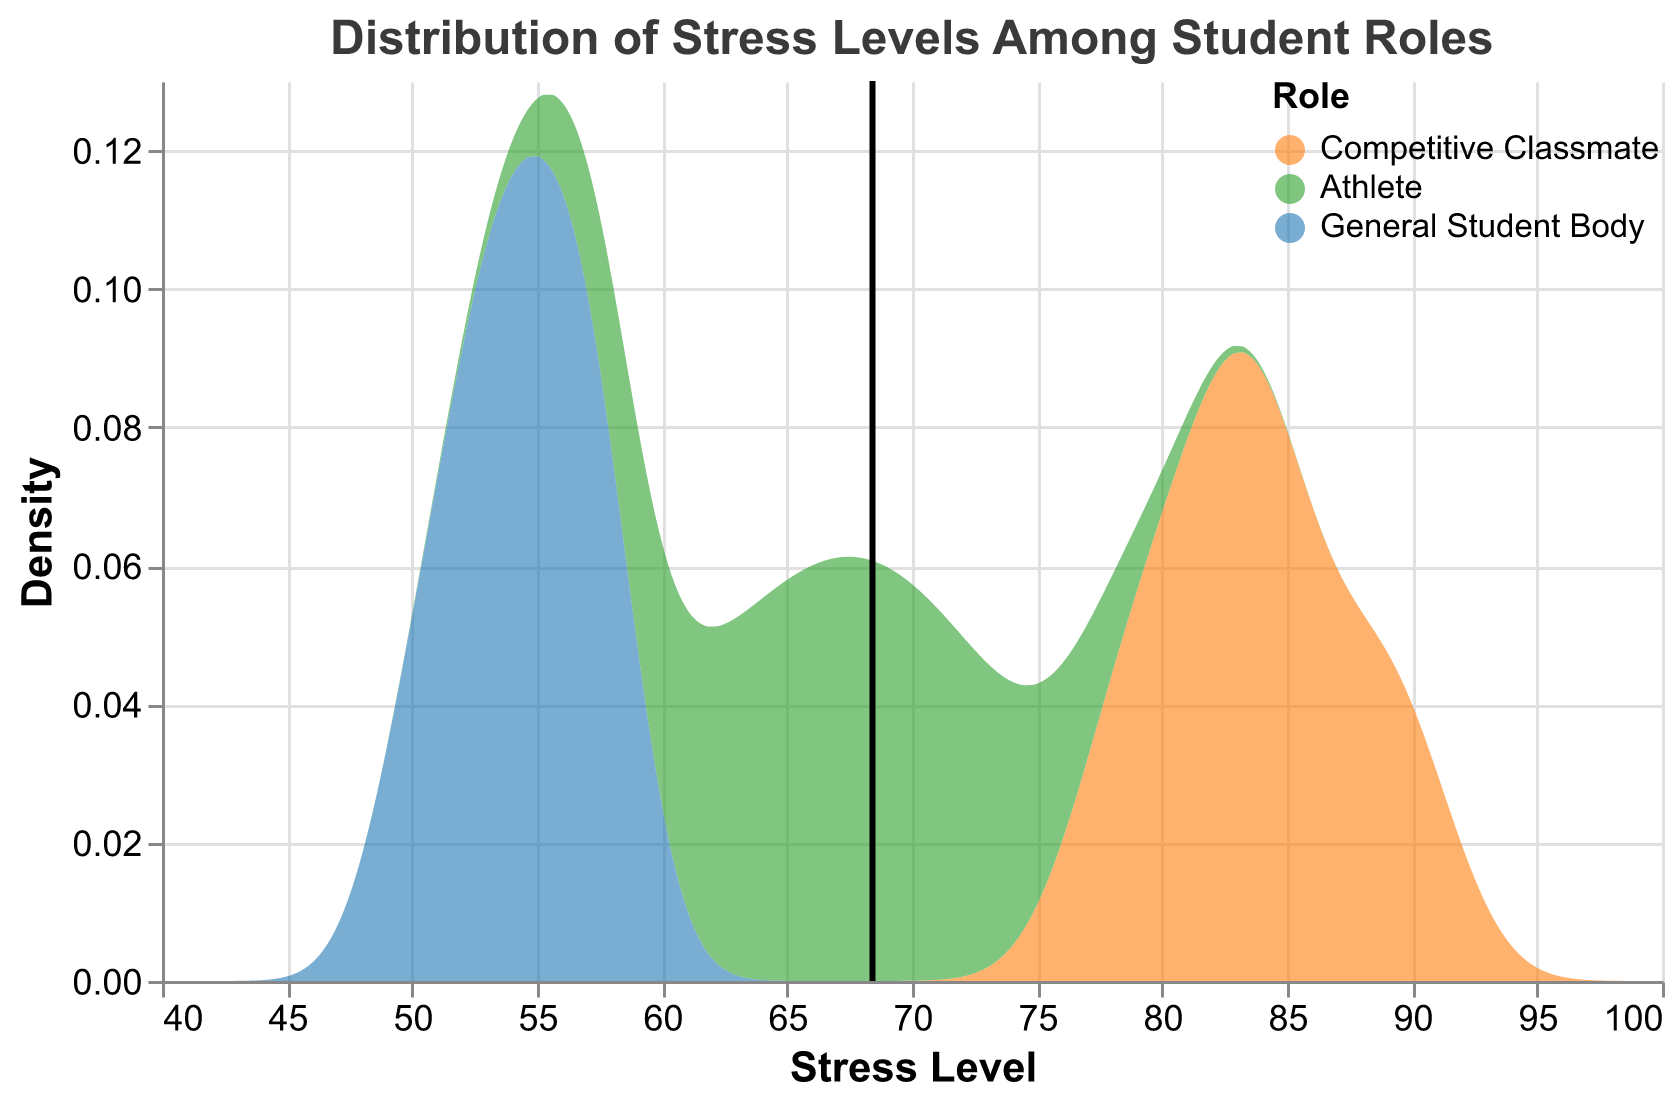What is the title of the plot? The title is displayed prominently at the top of the figure. It is "Distribution of Stress Levels Among Student Roles."
Answer: Distribution of Stress Levels Among Student Roles What stress level range does the plot cover? The x-axis of the plot shows the range of stress levels. It spans from 40 to 100.
Answer: 40 to 100 Which group of students has the highest mean stress level? The black rule in the plot represents the mean stress level for each group. The mean is highest for the Competitive Classmate group.
Answer: Competitive Classmate What color represents the Athletes in the plot? From the legend, the Athletes are represented by green.
Answer: Green What group has the lowest median stress level? By examining the density areas, the General Student Body has lower stress levels on average compared to the other groups.
Answer: General Student Body What is the median stress level for Competitive Classmates? To find the median, observe the distribution and identify the midpoint. For Competitive Classmates, the median appears new 83-84.
Answer: 83-84 Which group shows the widest distribution of stress levels? The Competitive Classmate group has the widest range of stress levels from 78 to 90.
Answer: Competitive Classmate Are there any groups with distinct peaks in their stress level distribution? Yes, the General Student Body has a distinct peak around the 54-55 stress level mark.
Answer: Yes Between Athletes and General Students, which group has a higher density around the 60 stress level? Examining the density lines, Athletes have a higher density around the 60 stress level than the General Student Body.
Answer: Athletes How do the stress levels of athletes compare to those of the competitive classmates? Generally, athletes have lower stress levels (between 60-75) compared to the competitive classmates who have higher stress levels (mostly above 80).
Answer: Lower 